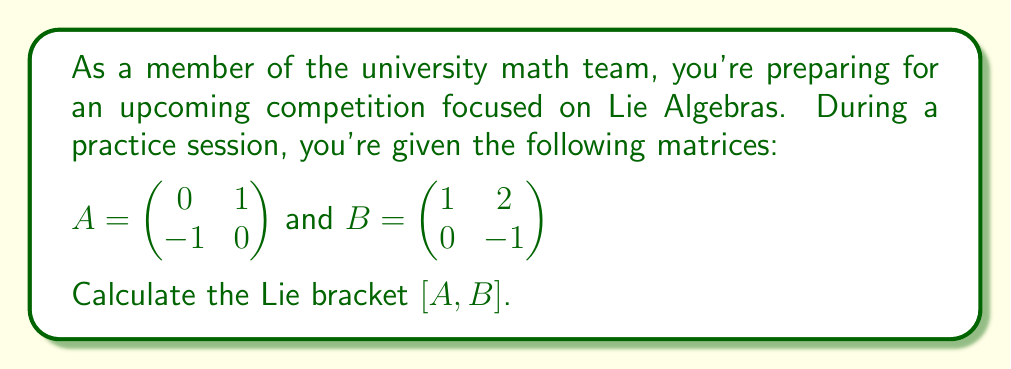What is the answer to this math problem? To calculate the Lie bracket of two matrices A and B, we use the formula:

$[A,B] = AB - BA$

Let's break this down step-by-step:

1) First, we need to calculate AB:

   $AB = \begin{pmatrix}
   0 & 1 \\
   -1 & 0
   \end{pmatrix} \begin{pmatrix}
   1 & 2 \\
   0 & -1
   \end{pmatrix} = \begin{pmatrix}
   (0 \cdot 1 + 1 \cdot 0) & (0 \cdot 2 + 1 \cdot (-1)) \\
   (-1 \cdot 1 + 0 \cdot 0) & (-1 \cdot 2 + 0 \cdot (-1))
   \end{pmatrix} = \begin{pmatrix}
   0 & -1 \\
   -1 & -2
   \end{pmatrix}$

2) Next, we calculate BA:

   $BA = \begin{pmatrix}
   1 & 2 \\
   0 & -1
   \end{pmatrix} \begin{pmatrix}
   0 & 1 \\
   -1 & 0
   \end{pmatrix} = \begin{pmatrix}
   (1 \cdot 0 + 2 \cdot (-1)) & (1 \cdot 1 + 2 \cdot 0) \\
   (0 \cdot 0 + (-1) \cdot (-1)) & (0 \cdot 1 + (-1) \cdot 0)
   \end{pmatrix} = \begin{pmatrix}
   -2 & 1 \\
   1 & 0
   \end{pmatrix}$

3) Finally, we subtract BA from AB:

   $[A,B] = AB - BA = \begin{pmatrix}
   0 & -1 \\
   -1 & -2
   \end{pmatrix} - \begin{pmatrix}
   -2 & 1 \\
   1 & 0
   \end{pmatrix} = \begin{pmatrix}
   0-(-2) & -1-1 \\
   -1-1 & -2-0
   \end{pmatrix} = \begin{pmatrix}
   2 & -2 \\
   -2 & -2
   \end{pmatrix}$
Answer: $[A,B] = \begin{pmatrix}
2 & -2 \\
-2 & -2
\end{pmatrix}$ 